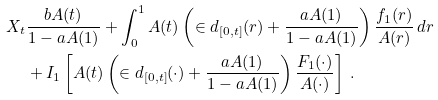<formula> <loc_0><loc_0><loc_500><loc_500>X _ { t } & \frac { b A ( t ) } { 1 - a A ( 1 ) } + \int _ { 0 } ^ { 1 } A ( t ) \left ( \in d _ { [ 0 , t ] } ( r ) + \frac { a A ( 1 ) } { 1 - a A ( 1 ) } \right ) \frac { f _ { 1 } ( r ) } { A ( r ) } \, d r \\ & + I _ { 1 } \left [ A ( t ) \left ( \in d _ { [ 0 , t ] } ( \cdot ) + \frac { a A ( 1 ) } { 1 - a A ( 1 ) } \right ) \frac { F _ { 1 } ( \cdot ) } { A ( \cdot ) } \right ] \ .</formula> 